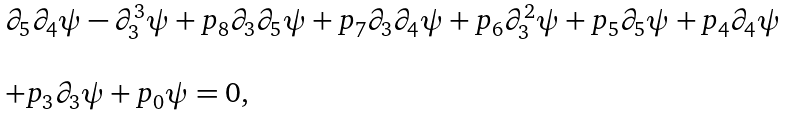Convert formula to latex. <formula><loc_0><loc_0><loc_500><loc_500>\begin{array} { l } \partial _ { 5 } \partial _ { 4 } \psi - \partial _ { 3 } ^ { 3 } \psi + p _ { 8 } \partial _ { 3 } \partial _ { 5 } \psi + p _ { 7 } \partial _ { 3 } \partial _ { 4 } \psi + p _ { 6 } \partial _ { 3 } ^ { 2 } \psi + p _ { 5 } \partial _ { 5 } \psi + p _ { 4 } \partial _ { 4 } \psi \\ \\ + p _ { 3 } \partial _ { 3 } \psi + p _ { 0 } \psi = 0 , \end{array}</formula> 